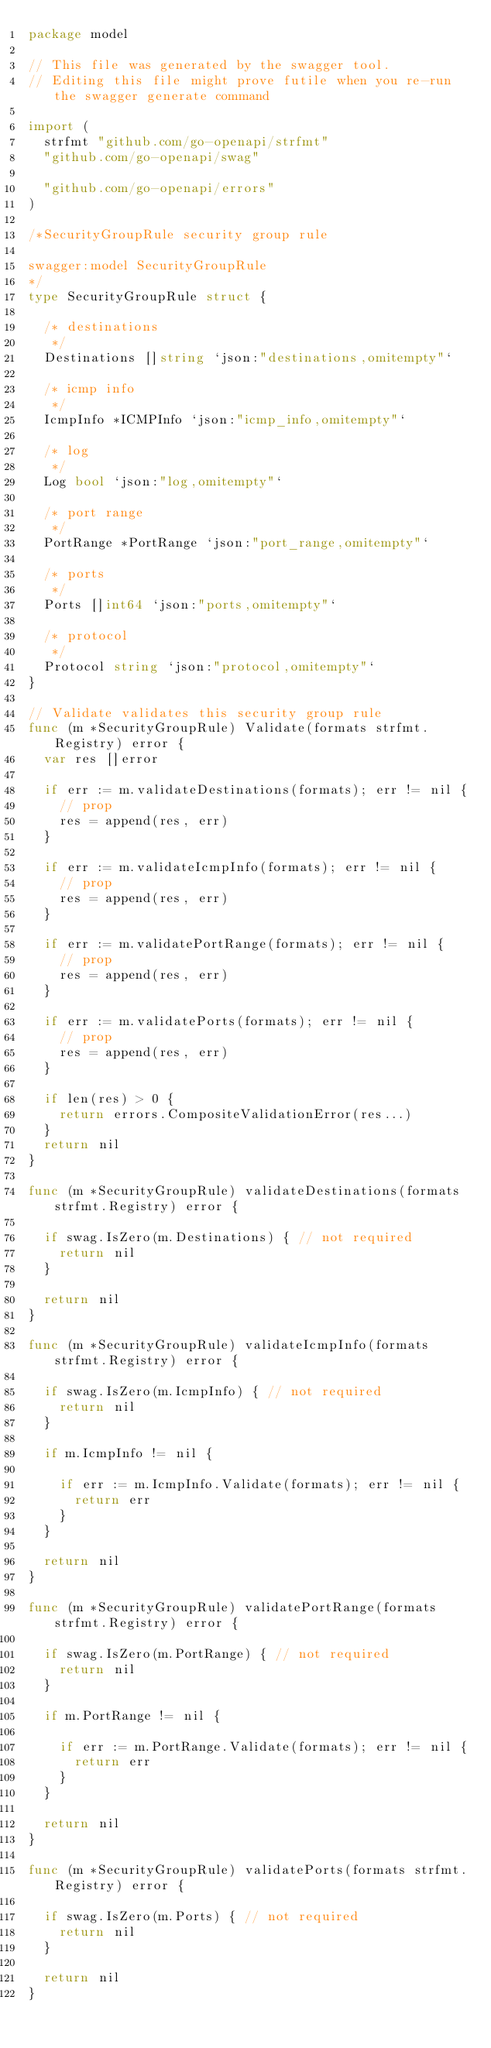<code> <loc_0><loc_0><loc_500><loc_500><_Go_>package model

// This file was generated by the swagger tool.
// Editing this file might prove futile when you re-run the swagger generate command

import (
	strfmt "github.com/go-openapi/strfmt"
	"github.com/go-openapi/swag"

	"github.com/go-openapi/errors"
)

/*SecurityGroupRule security group rule

swagger:model SecurityGroupRule
*/
type SecurityGroupRule struct {

	/* destinations
	 */
	Destinations []string `json:"destinations,omitempty"`

	/* icmp info
	 */
	IcmpInfo *ICMPInfo `json:"icmp_info,omitempty"`

	/* log
	 */
	Log bool `json:"log,omitempty"`

	/* port range
	 */
	PortRange *PortRange `json:"port_range,omitempty"`

	/* ports
	 */
	Ports []int64 `json:"ports,omitempty"`

	/* protocol
	 */
	Protocol string `json:"protocol,omitempty"`
}

// Validate validates this security group rule
func (m *SecurityGroupRule) Validate(formats strfmt.Registry) error {
	var res []error

	if err := m.validateDestinations(formats); err != nil {
		// prop
		res = append(res, err)
	}

	if err := m.validateIcmpInfo(formats); err != nil {
		// prop
		res = append(res, err)
	}

	if err := m.validatePortRange(formats); err != nil {
		// prop
		res = append(res, err)
	}

	if err := m.validatePorts(formats); err != nil {
		// prop
		res = append(res, err)
	}

	if len(res) > 0 {
		return errors.CompositeValidationError(res...)
	}
	return nil
}

func (m *SecurityGroupRule) validateDestinations(formats strfmt.Registry) error {

	if swag.IsZero(m.Destinations) { // not required
		return nil
	}

	return nil
}

func (m *SecurityGroupRule) validateIcmpInfo(formats strfmt.Registry) error {

	if swag.IsZero(m.IcmpInfo) { // not required
		return nil
	}

	if m.IcmpInfo != nil {

		if err := m.IcmpInfo.Validate(formats); err != nil {
			return err
		}
	}

	return nil
}

func (m *SecurityGroupRule) validatePortRange(formats strfmt.Registry) error {

	if swag.IsZero(m.PortRange) { // not required
		return nil
	}

	if m.PortRange != nil {

		if err := m.PortRange.Validate(formats); err != nil {
			return err
		}
	}

	return nil
}

func (m *SecurityGroupRule) validatePorts(formats strfmt.Registry) error {

	if swag.IsZero(m.Ports) { // not required
		return nil
	}

	return nil
}
</code> 